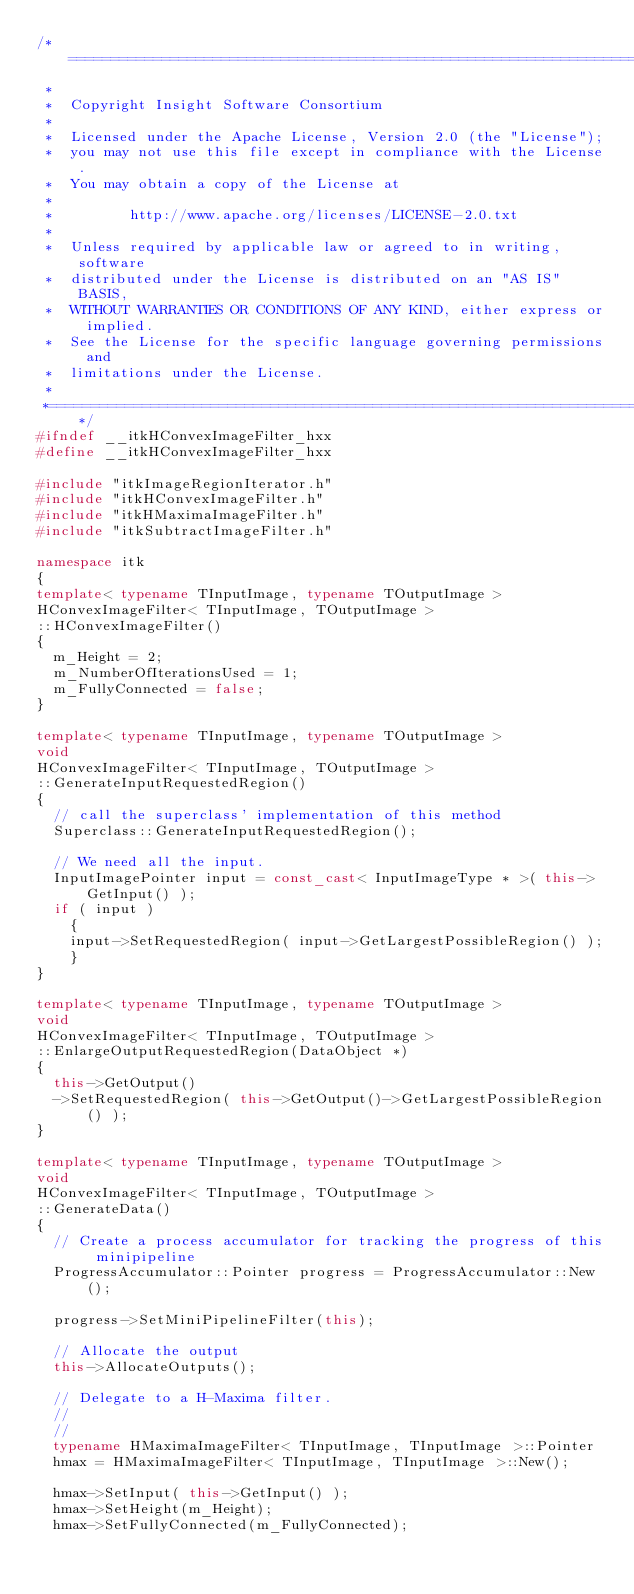Convert code to text. <code><loc_0><loc_0><loc_500><loc_500><_C++_>/*=========================================================================
 *
 *  Copyright Insight Software Consortium
 *
 *  Licensed under the Apache License, Version 2.0 (the "License");
 *  you may not use this file except in compliance with the License.
 *  You may obtain a copy of the License at
 *
 *         http://www.apache.org/licenses/LICENSE-2.0.txt
 *
 *  Unless required by applicable law or agreed to in writing, software
 *  distributed under the License is distributed on an "AS IS" BASIS,
 *  WITHOUT WARRANTIES OR CONDITIONS OF ANY KIND, either express or implied.
 *  See the License for the specific language governing permissions and
 *  limitations under the License.
 *
 *=========================================================================*/
#ifndef __itkHConvexImageFilter_hxx
#define __itkHConvexImageFilter_hxx

#include "itkImageRegionIterator.h"
#include "itkHConvexImageFilter.h"
#include "itkHMaximaImageFilter.h"
#include "itkSubtractImageFilter.h"

namespace itk
{
template< typename TInputImage, typename TOutputImage >
HConvexImageFilter< TInputImage, TOutputImage >
::HConvexImageFilter()
{
  m_Height = 2;
  m_NumberOfIterationsUsed = 1;
  m_FullyConnected = false;
}

template< typename TInputImage, typename TOutputImage >
void
HConvexImageFilter< TInputImage, TOutputImage >
::GenerateInputRequestedRegion()
{
  // call the superclass' implementation of this method
  Superclass::GenerateInputRequestedRegion();

  // We need all the input.
  InputImagePointer input = const_cast< InputImageType * >( this->GetInput() );
  if ( input )
    {
    input->SetRequestedRegion( input->GetLargestPossibleRegion() );
    }
}

template< typename TInputImage, typename TOutputImage >
void
HConvexImageFilter< TInputImage, TOutputImage >
::EnlargeOutputRequestedRegion(DataObject *)
{
  this->GetOutput()
  ->SetRequestedRegion( this->GetOutput()->GetLargestPossibleRegion() );
}

template< typename TInputImage, typename TOutputImage >
void
HConvexImageFilter< TInputImage, TOutputImage >
::GenerateData()
{
  // Create a process accumulator for tracking the progress of this minipipeline
  ProgressAccumulator::Pointer progress = ProgressAccumulator::New();

  progress->SetMiniPipelineFilter(this);

  // Allocate the output
  this->AllocateOutputs();

  // Delegate to a H-Maxima filter.
  //
  //
  typename HMaximaImageFilter< TInputImage, TInputImage >::Pointer
  hmax = HMaximaImageFilter< TInputImage, TInputImage >::New();

  hmax->SetInput( this->GetInput() );
  hmax->SetHeight(m_Height);
  hmax->SetFullyConnected(m_FullyConnected);
</code> 